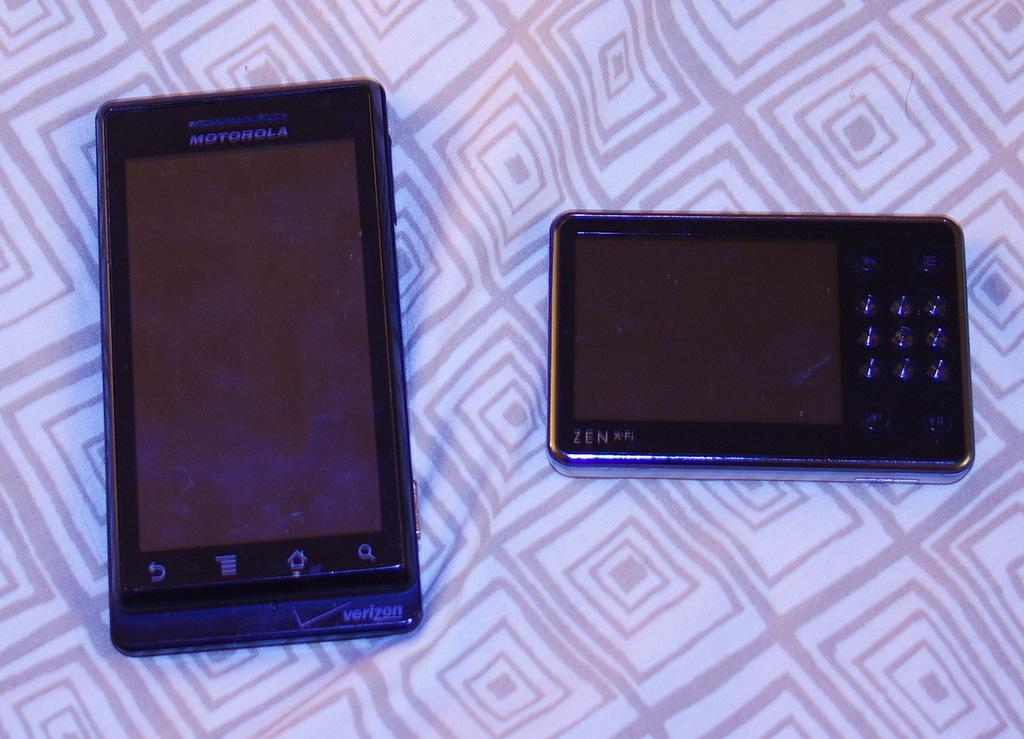<image>
Offer a succinct explanation of the picture presented. a Motorola phone is next to another dark phone 